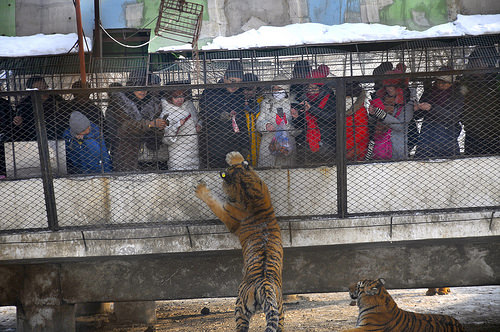<image>
Is there a tiger to the left of the woman? Yes. From this viewpoint, the tiger is positioned to the left side relative to the woman. Is there a tiger under the person? Yes. The tiger is positioned underneath the person, with the person above it in the vertical space. 